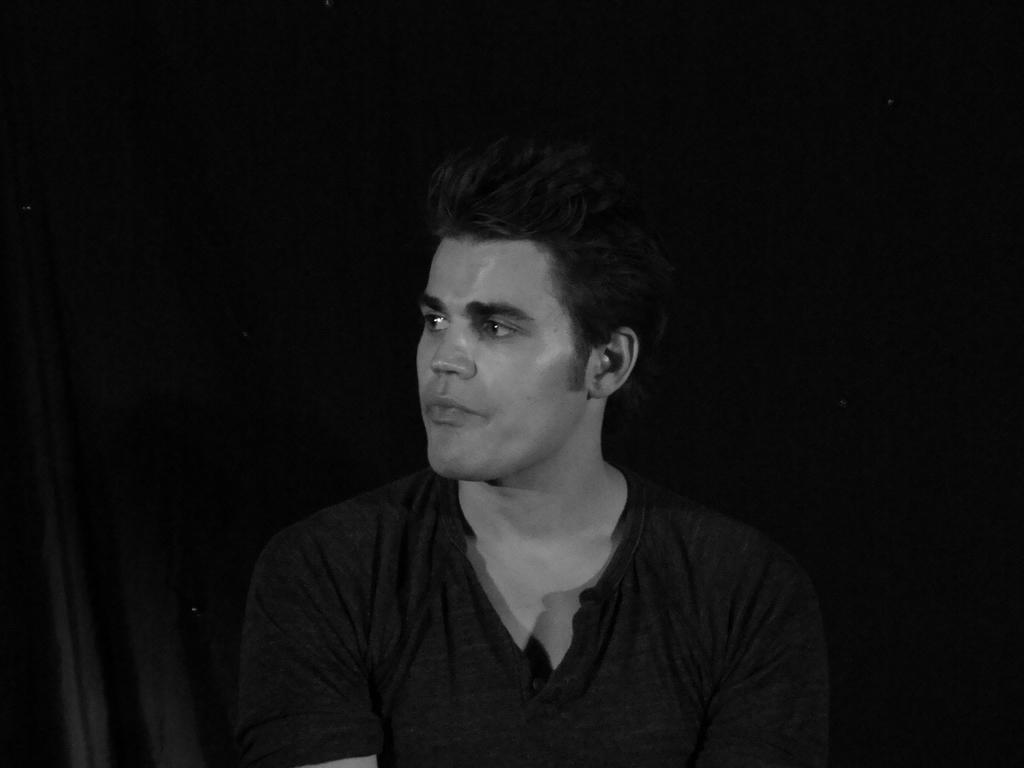In one or two sentences, can you explain what this image depicts? In the picture I can see a man wearing a black color T-shirt and he is in the middle of the image. 